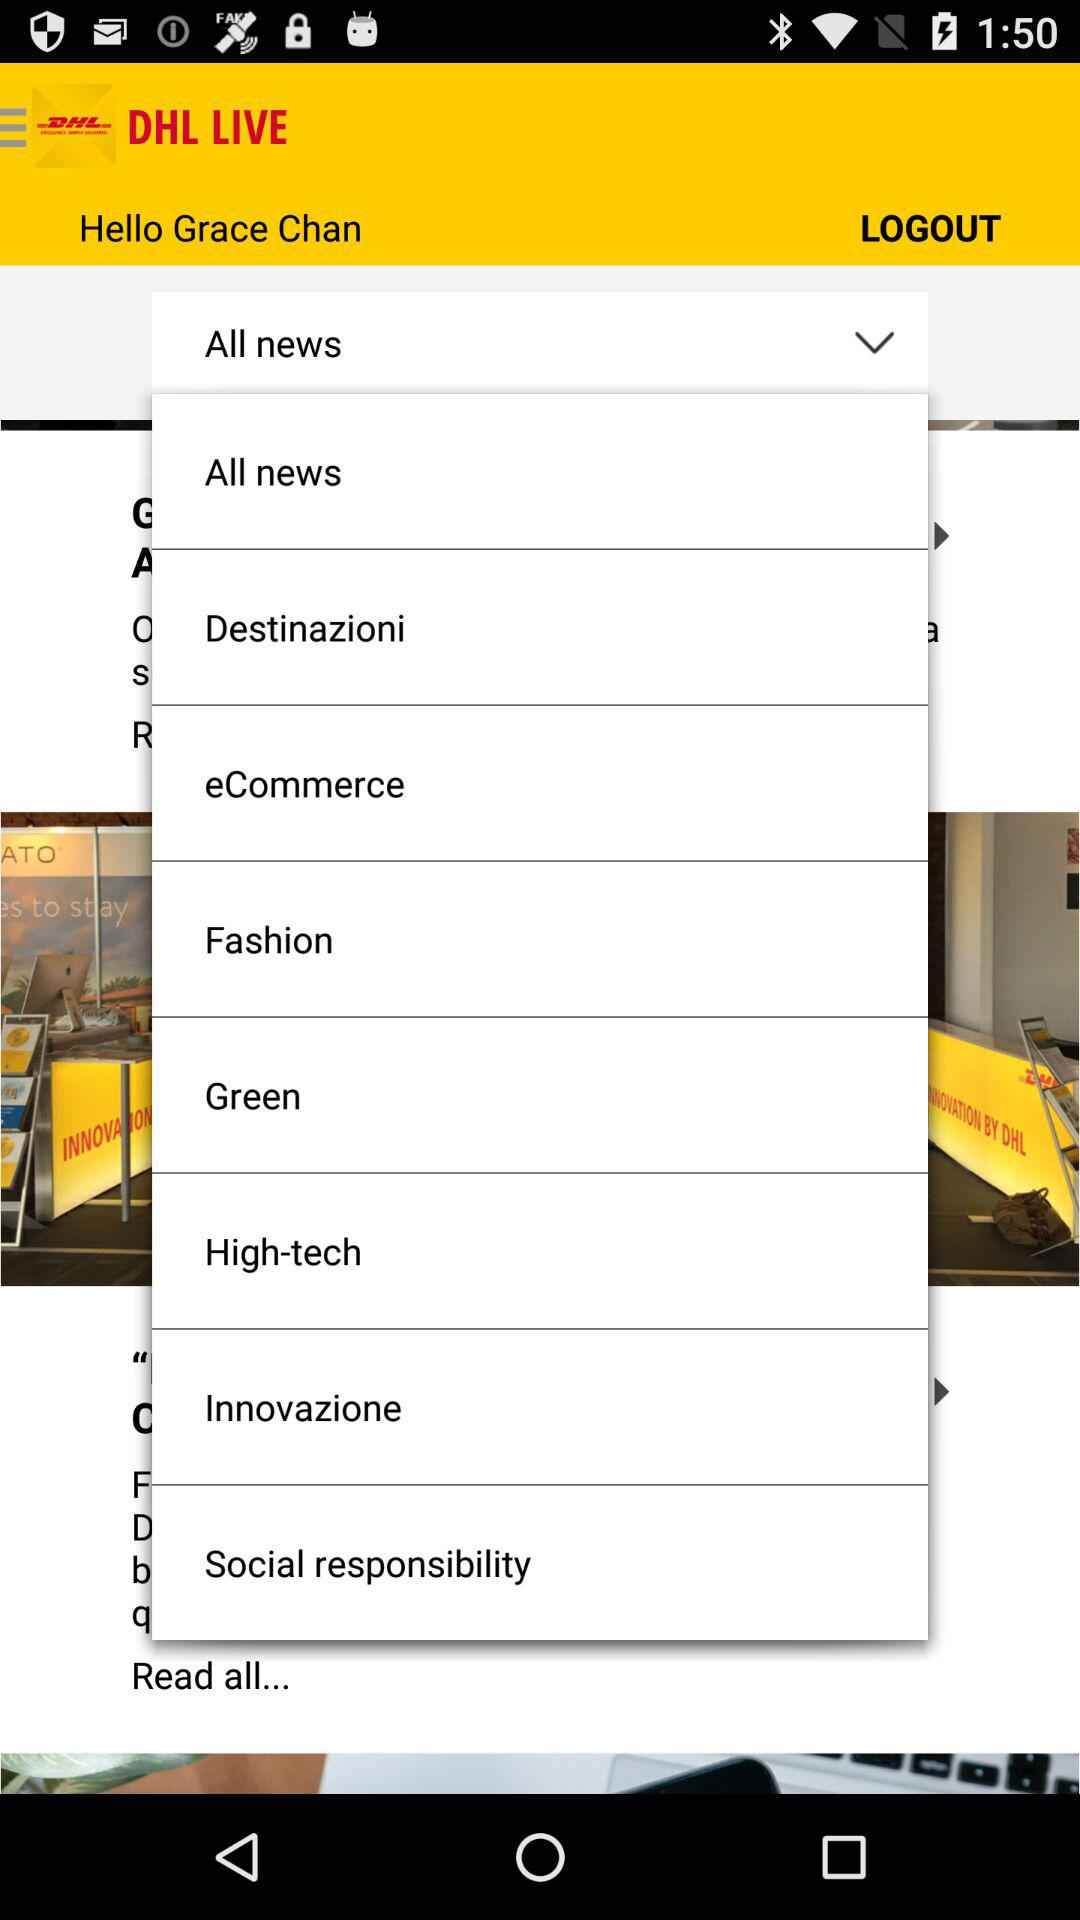What is the user name? The user name is Grace Chan. 